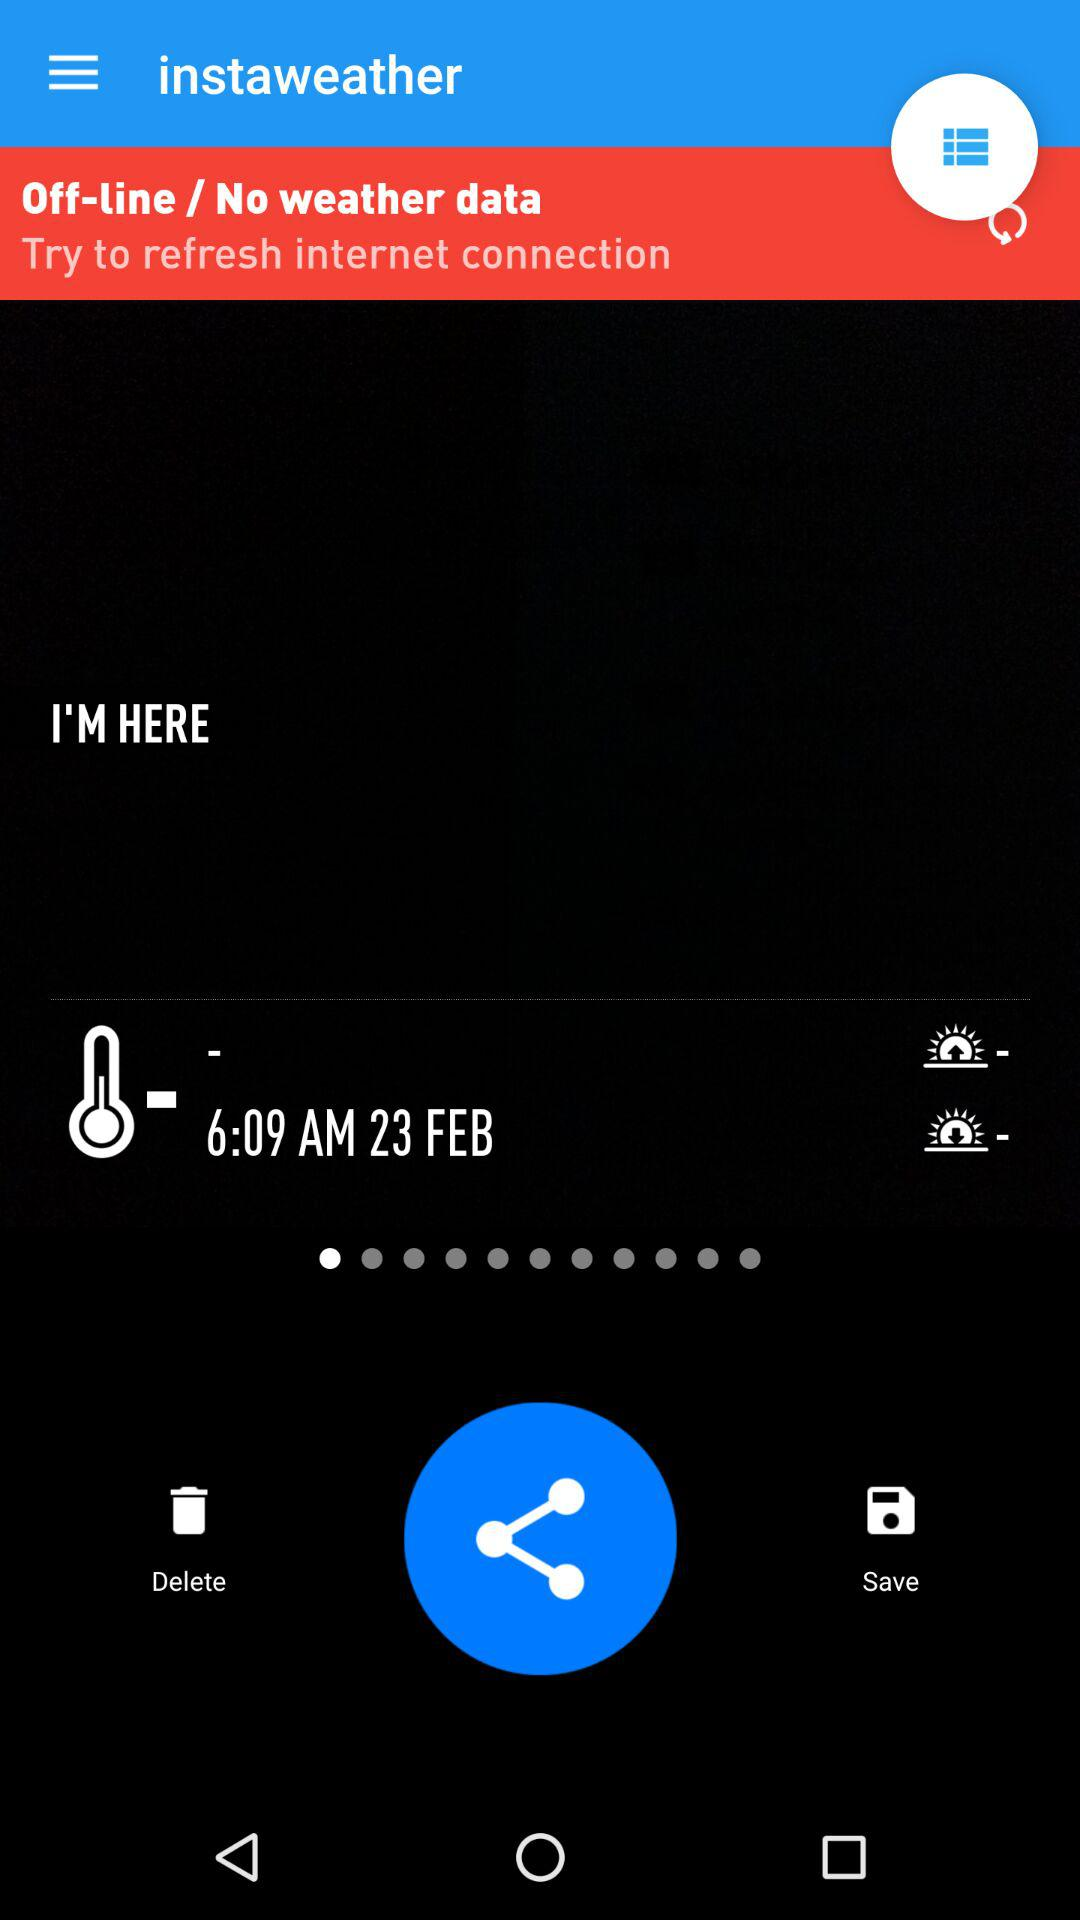What is the time? The time is 6:09 AM. 